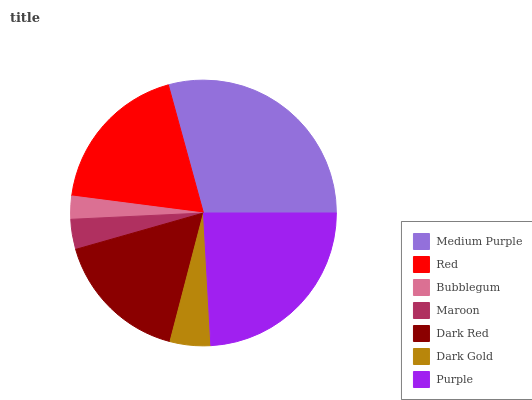Is Bubblegum the minimum?
Answer yes or no. Yes. Is Medium Purple the maximum?
Answer yes or no. Yes. Is Red the minimum?
Answer yes or no. No. Is Red the maximum?
Answer yes or no. No. Is Medium Purple greater than Red?
Answer yes or no. Yes. Is Red less than Medium Purple?
Answer yes or no. Yes. Is Red greater than Medium Purple?
Answer yes or no. No. Is Medium Purple less than Red?
Answer yes or no. No. Is Dark Red the high median?
Answer yes or no. Yes. Is Dark Red the low median?
Answer yes or no. Yes. Is Purple the high median?
Answer yes or no. No. Is Maroon the low median?
Answer yes or no. No. 